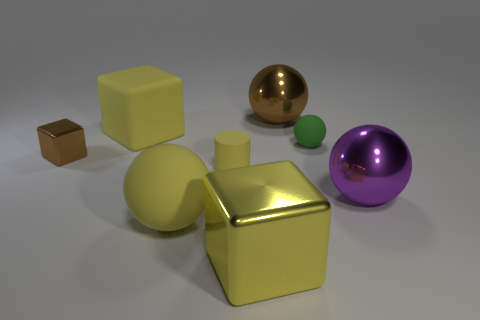There is a tiny rubber thing to the right of the big metal ball behind the big purple metal object; are there any yellow rubber cylinders to the right of it?
Your response must be concise. No. What number of brown metal objects have the same size as the purple sphere?
Give a very brief answer. 1. Do the metal block that is right of the brown cube and the shiny block that is to the left of the small yellow matte cylinder have the same size?
Keep it short and to the point. No. There is a big shiny thing that is both in front of the small matte sphere and to the left of the big purple metal object; what is its shape?
Provide a succinct answer. Cube. Are there any metal objects that have the same color as the rubber block?
Provide a short and direct response. Yes. Are there any tiny red matte objects?
Give a very brief answer. No. The ball on the left side of the yellow metallic object is what color?
Offer a terse response. Yellow. Do the brown cube and the shiny cube that is in front of the purple shiny object have the same size?
Provide a succinct answer. No. There is a object that is both left of the matte cylinder and behind the tiny block; what is its size?
Give a very brief answer. Large. Is there another small brown block that has the same material as the brown block?
Keep it short and to the point. No. 